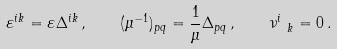<formula> <loc_0><loc_0><loc_500><loc_500>\varepsilon ^ { i k } = \varepsilon \Delta ^ { i k } \, , \quad ( \mu ^ { - 1 } ) _ { p q } = \frac { 1 } { \mu } \Delta _ { p q } \, , \quad \nu ^ { i } _ { \ k } = 0 \, .</formula> 